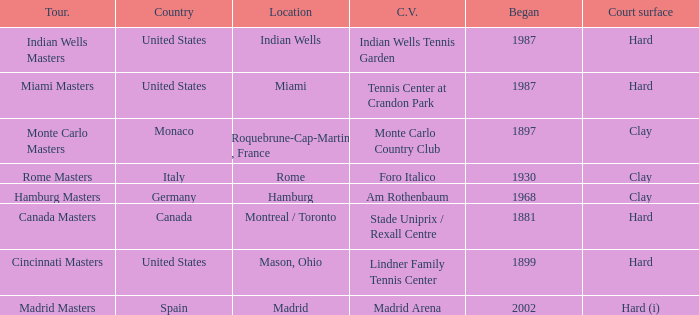What is the present location of the miami masters tournament? Tennis Center at Crandon Park. 